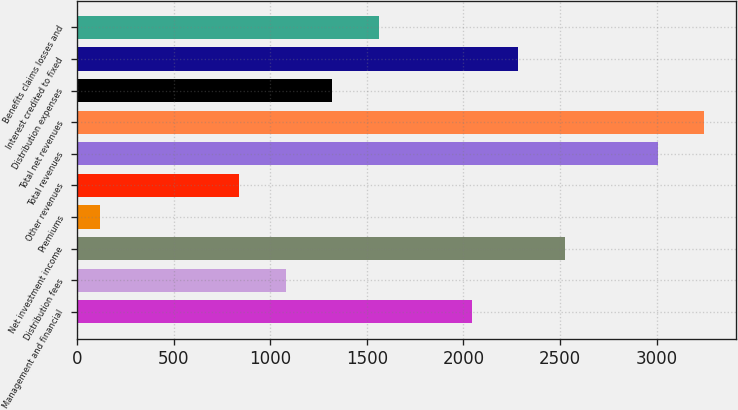Convert chart. <chart><loc_0><loc_0><loc_500><loc_500><bar_chart><fcel>Management and financial<fcel>Distribution fees<fcel>Net investment income<fcel>Premiums<fcel>Other revenues<fcel>Total revenues<fcel>Total net revenues<fcel>Distribution expenses<fcel>Interest credited to fixed<fcel>Benefits claims losses and<nl><fcel>2042.8<fcel>1080.4<fcel>2524<fcel>118<fcel>839.8<fcel>3005.2<fcel>3245.8<fcel>1321<fcel>2283.4<fcel>1561.6<nl></chart> 